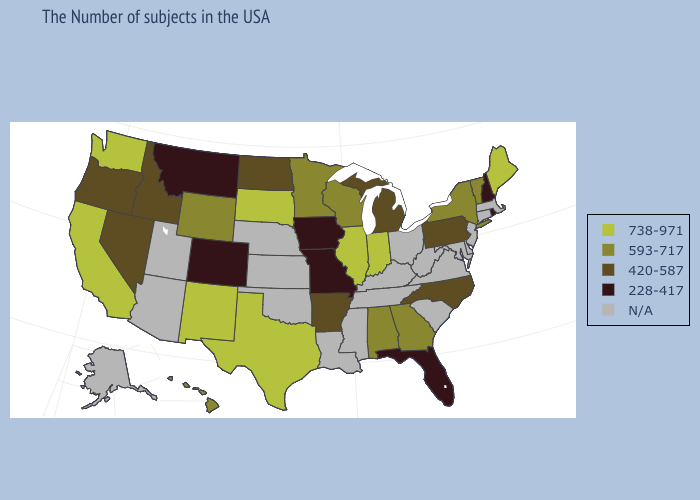Among the states that border Iowa , which have the highest value?
Short answer required. Illinois, South Dakota. Name the states that have a value in the range 593-717?
Short answer required. Vermont, New York, Georgia, Alabama, Wisconsin, Minnesota, Wyoming, Hawaii. Name the states that have a value in the range 738-971?
Short answer required. Maine, Indiana, Illinois, Texas, South Dakota, New Mexico, California, Washington. What is the highest value in states that border Washington?
Be succinct. 420-587. What is the highest value in states that border Delaware?
Quick response, please. 420-587. Name the states that have a value in the range N/A?
Concise answer only. Massachusetts, Connecticut, New Jersey, Delaware, Maryland, Virginia, South Carolina, West Virginia, Ohio, Kentucky, Tennessee, Mississippi, Louisiana, Kansas, Nebraska, Oklahoma, Utah, Arizona, Alaska. What is the value of California?
Give a very brief answer. 738-971. Among the states that border Nevada , which have the highest value?
Quick response, please. California. Does the map have missing data?
Keep it brief. Yes. What is the highest value in the MidWest ?
Concise answer only. 738-971. Does North Carolina have the lowest value in the South?
Give a very brief answer. No. Does Washington have the highest value in the USA?
Short answer required. Yes. Name the states that have a value in the range 593-717?
Concise answer only. Vermont, New York, Georgia, Alabama, Wisconsin, Minnesota, Wyoming, Hawaii. 